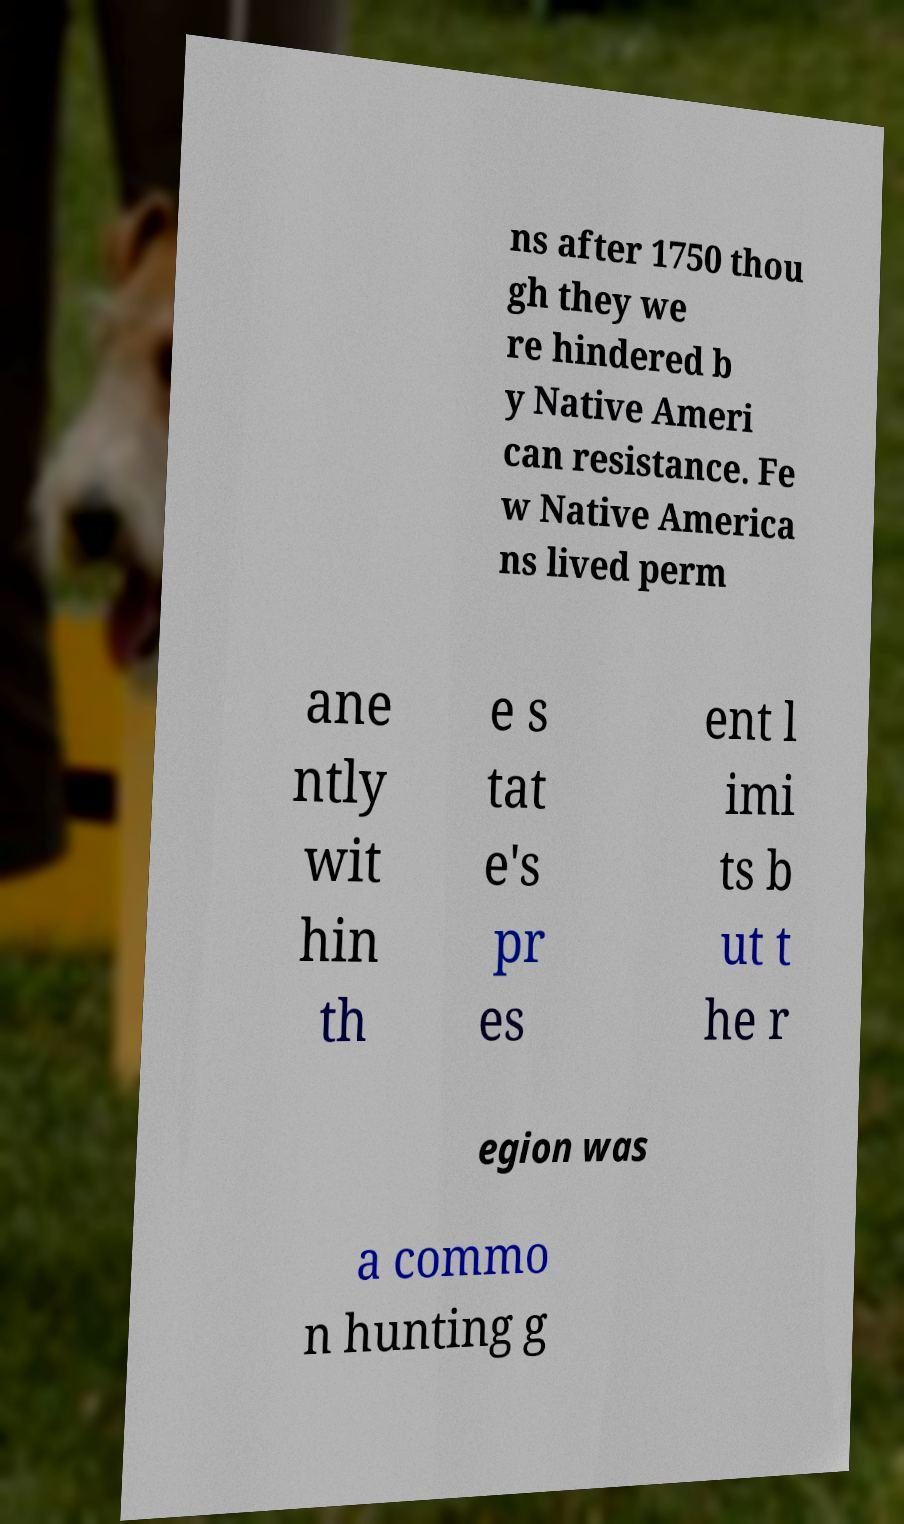There's text embedded in this image that I need extracted. Can you transcribe it verbatim? ns after 1750 thou gh they we re hindered b y Native Ameri can resistance. Fe w Native America ns lived perm ane ntly wit hin th e s tat e's pr es ent l imi ts b ut t he r egion was a commo n hunting g 